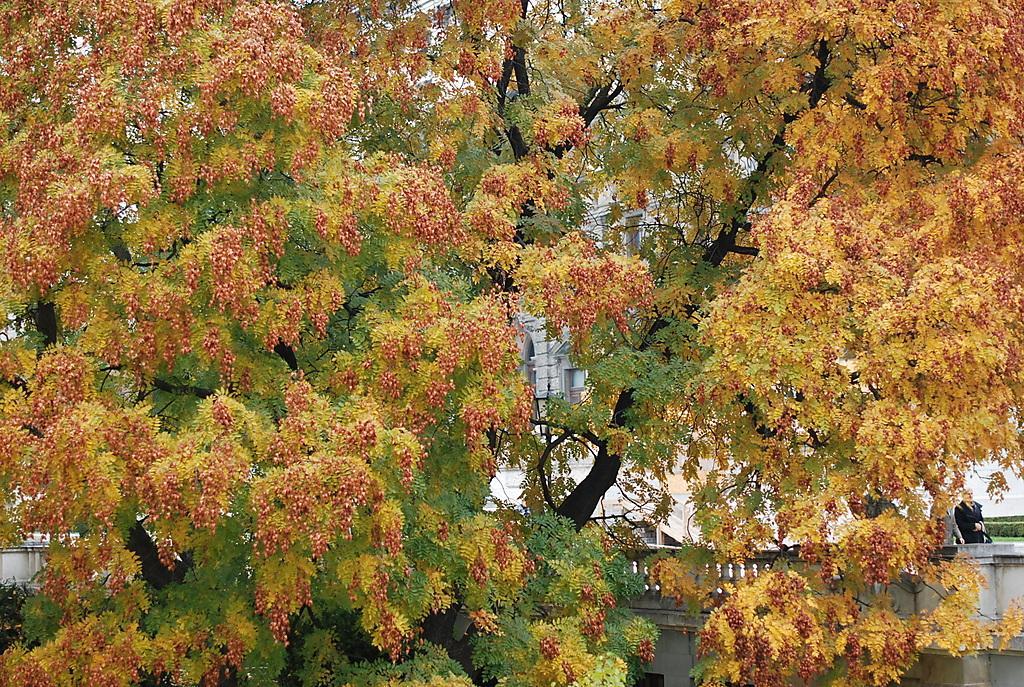Can you describe this image briefly? In this picture we can see a few trees. Behind these trees, we can see a few people on a building. 